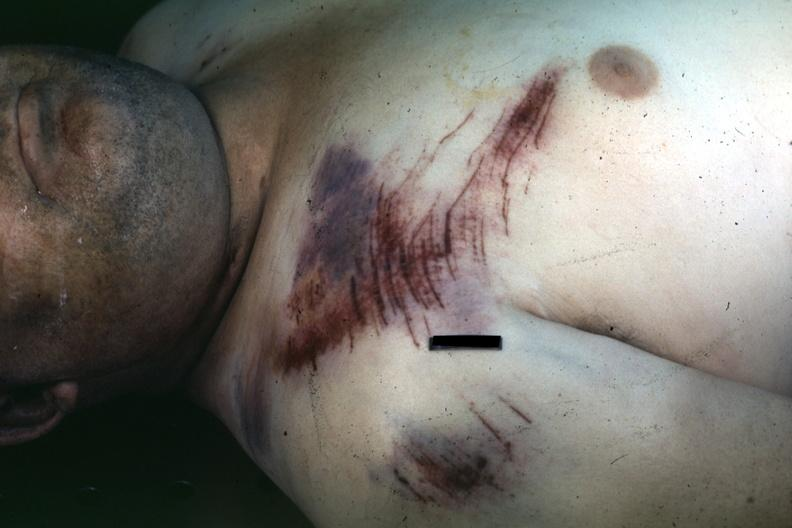s contusion and abrasion focus present?
Answer the question using a single word or phrase. Yes 